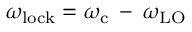<formula> <loc_0><loc_0><loc_500><loc_500>\omega _ { l o c k } = \omega _ { c } \, - \, \omega _ { L O }</formula> 